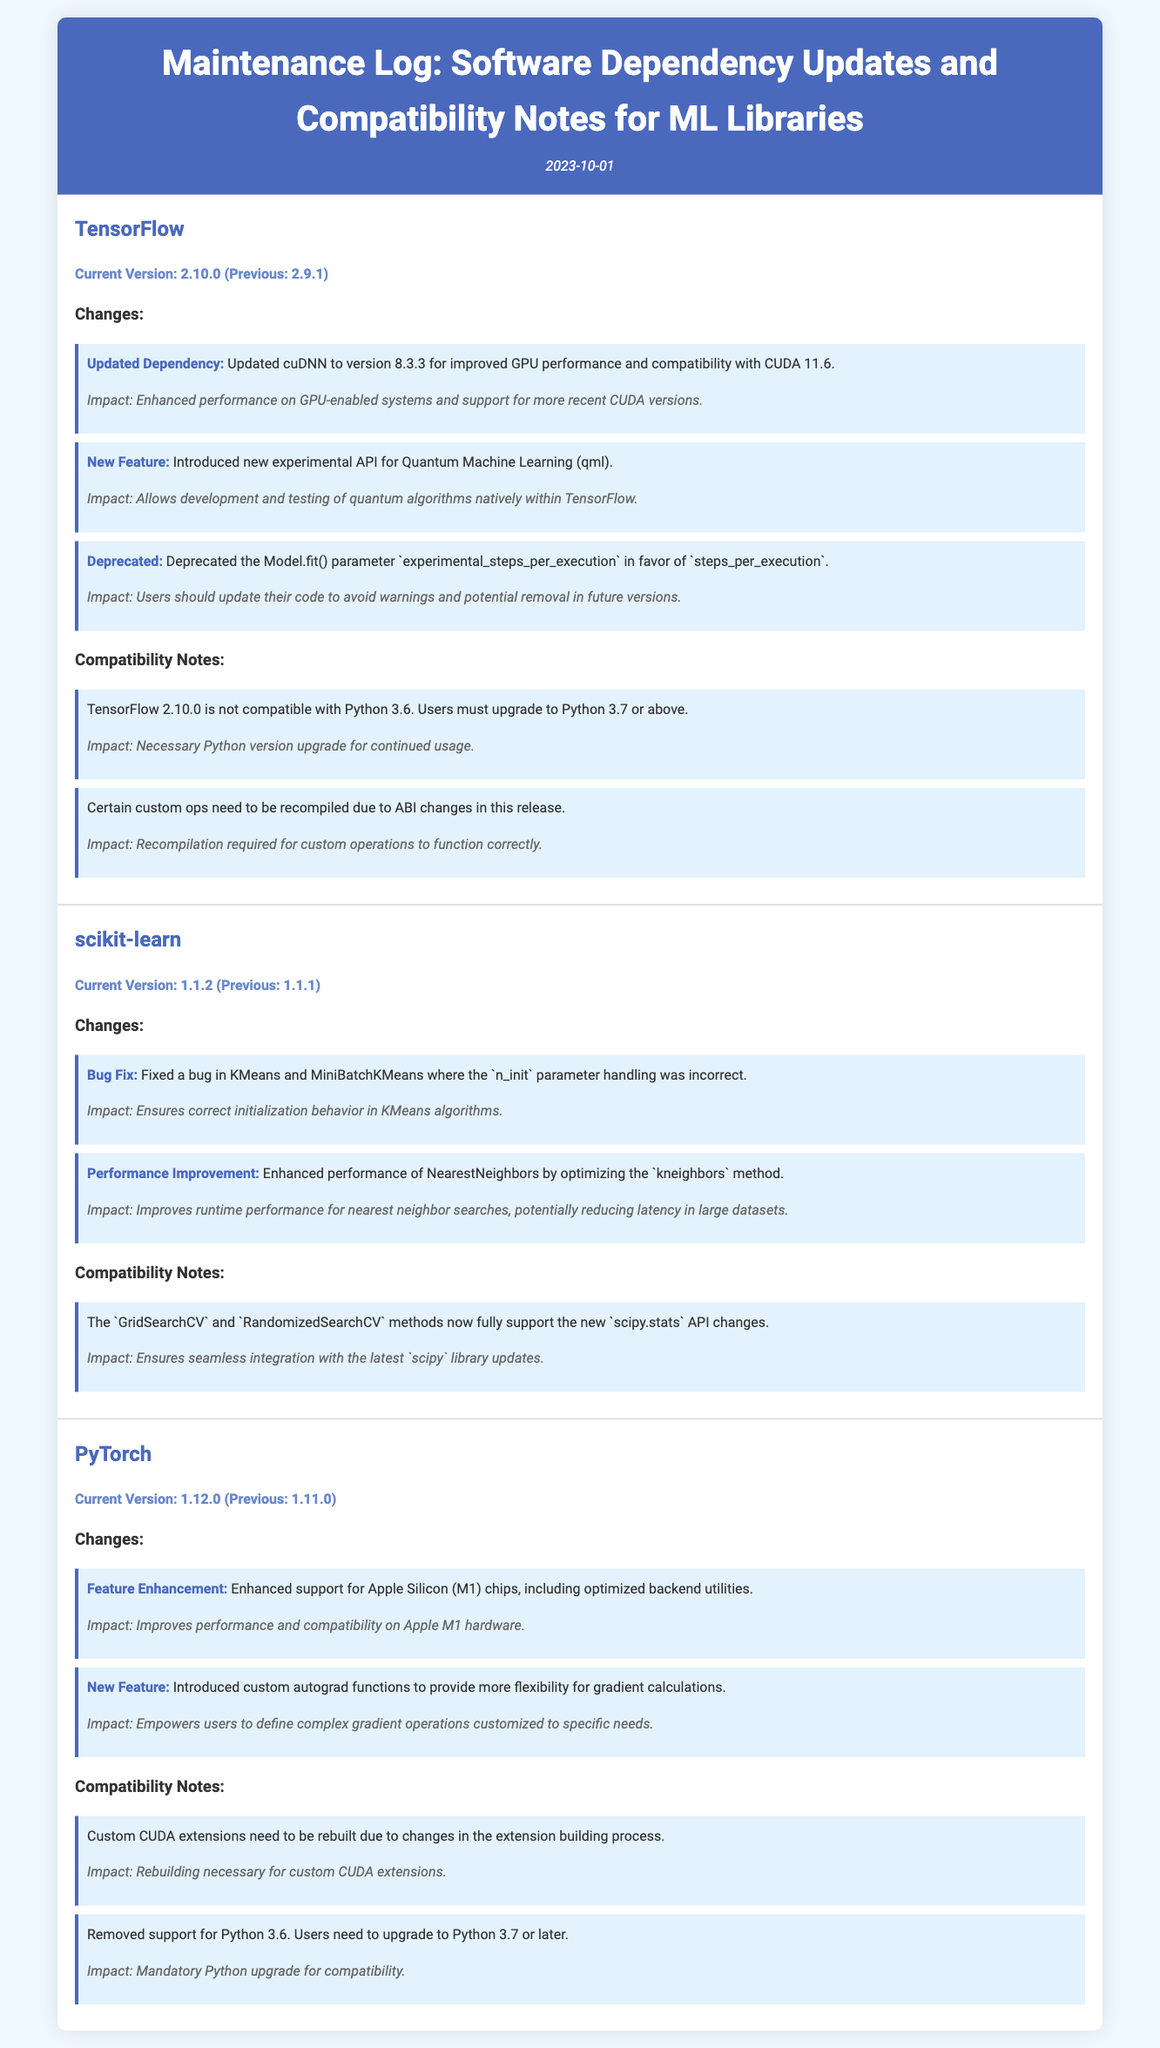What is the current version of TensorFlow? The current version is specified in the document under TensorFlow, which lists it as 2.10.0.
Answer: 2.10.0 What is the previous version of scikit-learn? The previous version of scikit-learn is mentioned in the document as 1.1.1.
Answer: 1.1.1 What new feature was introduced in TensorFlow? The document notes that TensorFlow introduced a new experimental API for Quantum Machine Learning (qml).
Answer: Quantum Machine Learning (qml) What is one of the impacts of updating cuDNN in TensorFlow? The impact mentioned in the document includes enhanced performance on GPU-enabled systems.
Answer: Enhanced performance on GPU-enabled systems Which library supports the new scipy.stats API changes? The compatibility notes in the document indicate that scikit-learn supports the new scipy.stats API changes.
Answer: scikit-learn What is one compatibility note for PyTorch? The document states that custom CUDA extensions need to be rebuilt due to changes in the extension building process.
Answer: Custom CUDA extensions need to be rebuilt How has PyTorch improved its compatibility? The document indicates that PyTorch enhanced support for Apple Silicon (M1) chips.
Answer: Apple Silicon (M1) chips What is the stability impact of deprecated parameters in TensorFlow? The document mentions that users should update their code to avoid warnings and potential removal in future versions.
Answer: Warnings and potential removal in future versions What version of Python is required for TensorFlow 2.10.0? The document explicitly states that users must upgrade to Python 3.7 or above for TensorFlow 2.10.0.
Answer: Python 3.7 or above 